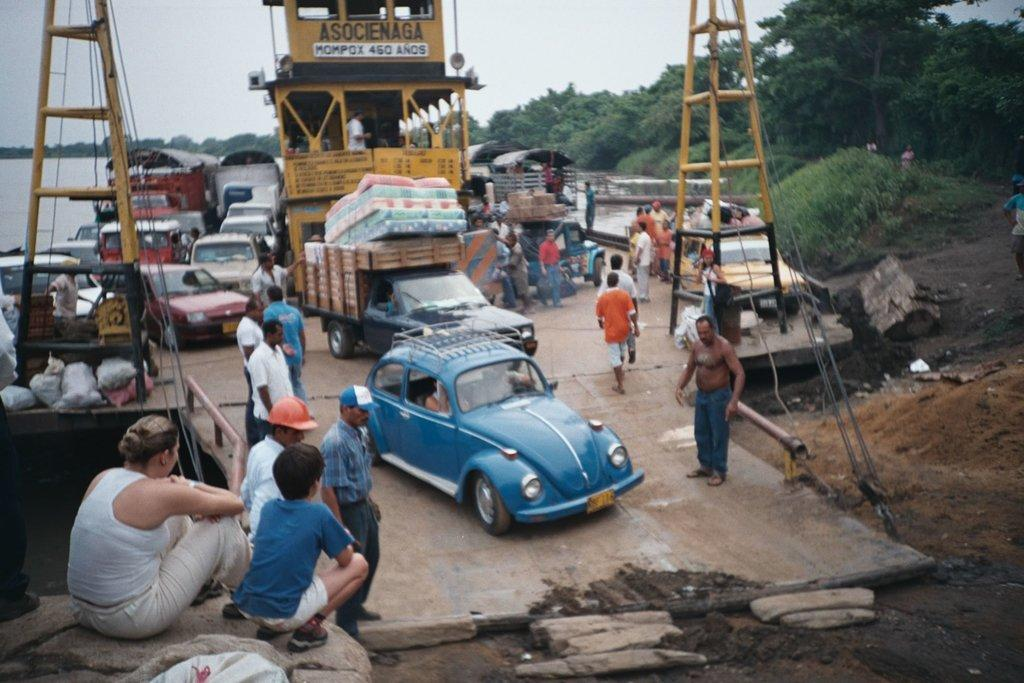What can be seen in the image that moves or travels? There are vehicles in the image that move or travel. What else can be seen on the road in the image? There are people on the road in the image. What natural feature is located on the left side of the image? There is a river on the left side of the image. What can be seen in the background of the image? There are trees and the sky visible in the background of the image. What type of jelly is being used to pave the road in the image? There is no jelly present in the image; it is a road with vehicles and people. What authority figure can be seen directing traffic in the image? There is no authority figure directing traffic in the image; it is a scene of vehicles and people on the road. 